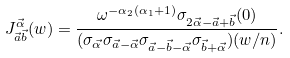Convert formula to latex. <formula><loc_0><loc_0><loc_500><loc_500>J _ { \vec { a } \vec { b } } ^ { \vec { \alpha } } ( w ) = \frac { \omega ^ { - \alpha _ { 2 } ( \alpha _ { 1 } + 1 ) } \sigma _ { 2 \vec { \alpha } - \vec { a } + \vec { b } } ( 0 ) } { ( \sigma _ { \vec { \alpha } } \sigma _ { \vec { a } - \vec { \alpha } } \sigma _ { \vec { a } - \vec { b } - \vec { \alpha } } \sigma _ { \vec { b } + \vec { \alpha } } ) ( w / n ) } .</formula> 